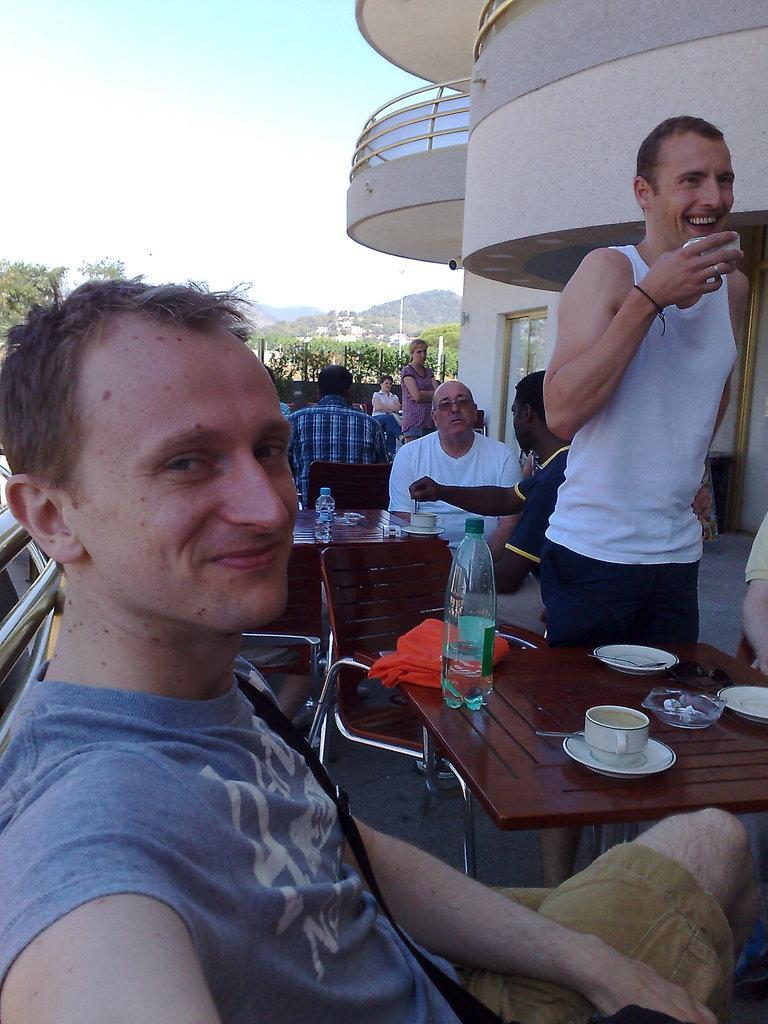Can you describe this image briefly? Here we can see few persons. There are tables, chairs, bottles, cups, saucers, and bowls. In the background we can see a building, trees, and sky. 